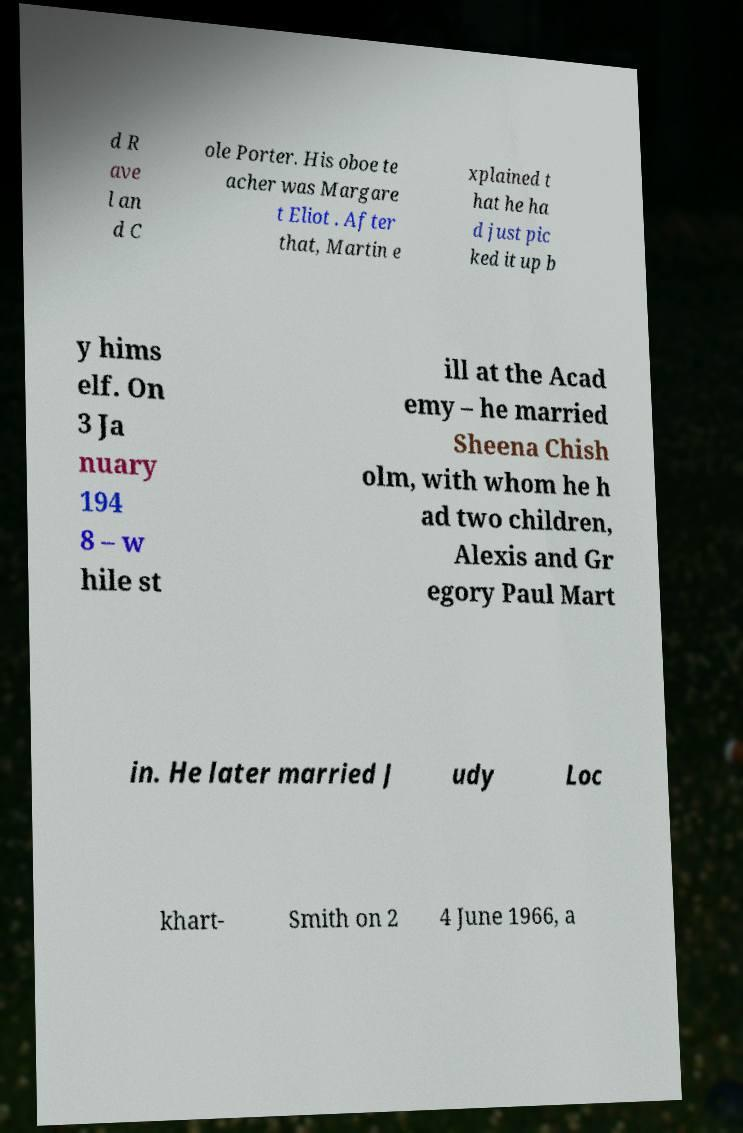Please read and relay the text visible in this image. What does it say? d R ave l an d C ole Porter. His oboe te acher was Margare t Eliot . After that, Martin e xplained t hat he ha d just pic ked it up b y hims elf. On 3 Ja nuary 194 8 – w hile st ill at the Acad emy – he married Sheena Chish olm, with whom he h ad two children, Alexis and Gr egory Paul Mart in. He later married J udy Loc khart- Smith on 2 4 June 1966, a 